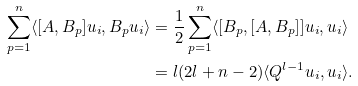Convert formula to latex. <formula><loc_0><loc_0><loc_500><loc_500>\sum _ { p = 1 } ^ { n } \langle [ A , B _ { p } ] u _ { i } , B _ { p } u _ { i } \rangle & = \frac { 1 } { 2 } \sum _ { p = 1 } ^ { n } \langle [ B _ { p } , [ A , B _ { p } ] ] u _ { i } , u _ { i } \rangle \\ & = l ( 2 l + n - 2 ) \langle Q ^ { l - 1 } u _ { i } , u _ { i } \rangle .</formula> 